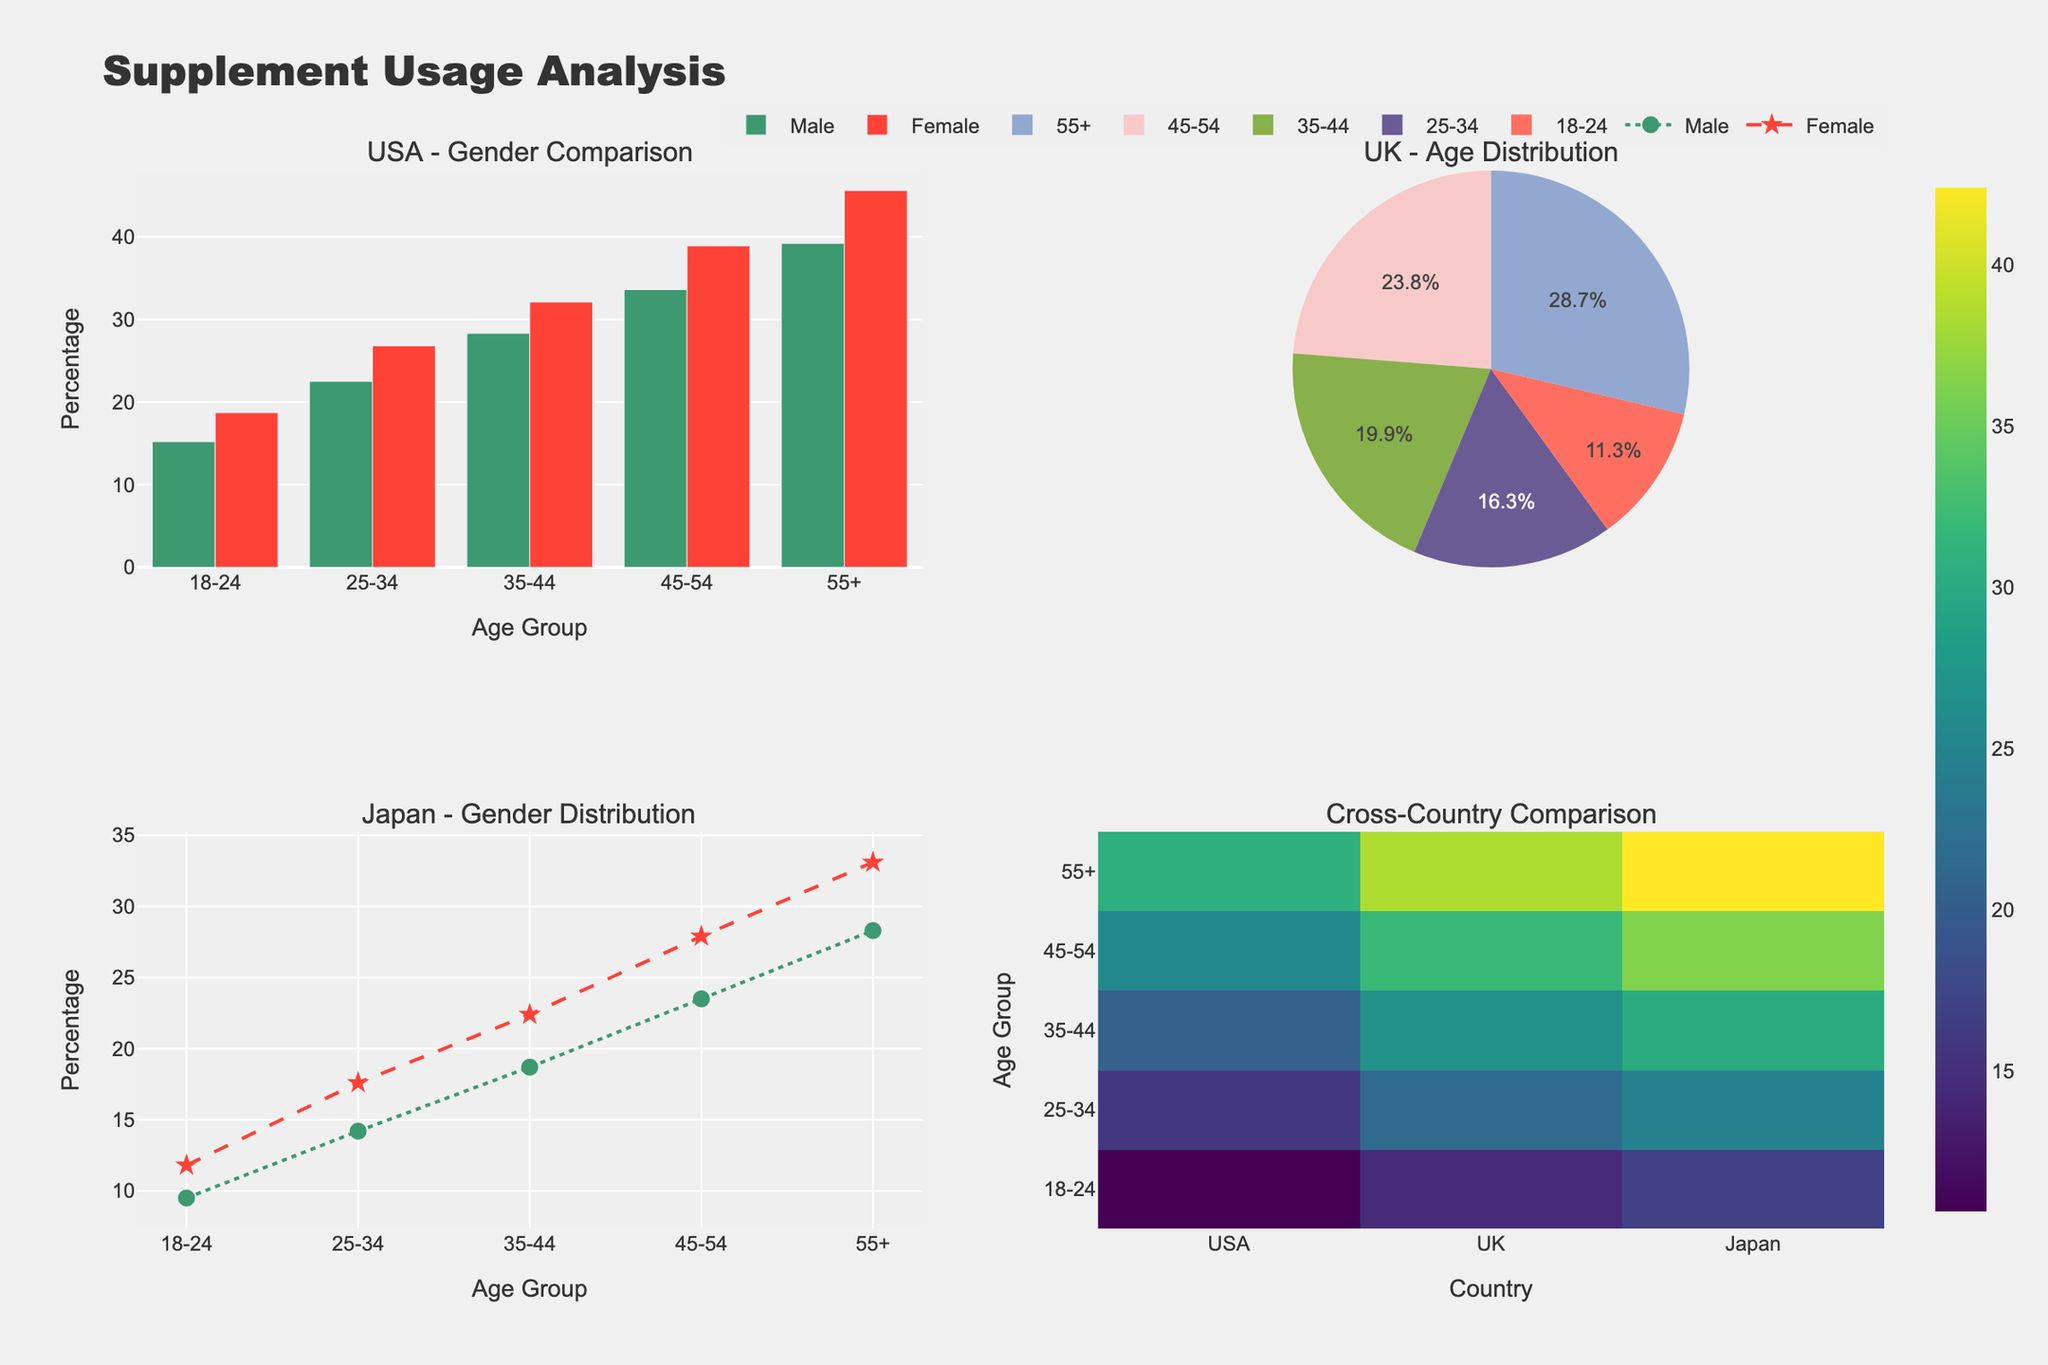What's the title of the entire figure? The title is displayed at the top of the figure. It reads "Supplement Usage Analysis".
Answer: Supplement Usage Analysis What type of chart is used to represent the gender distribution of supplement users in Japan? Observing the bottom-left plot, we see that gender distribution in Japan is depicted using a scatter plot with lines connecting the points.
Answer: Scatter plot In the USA - Gender Comparison plot, what is the percentage of male supplement users in the 35-44 age group? In the first subplot, the percentage for males in the 35-44 age group can be read from the green bar corresponding to this age group.
Answer: 28.3% How does the percentage of female supplement users in the 25-34 age group in the UK compare to the percentage in the USA? Compare the height of the pink bar in the USA plot for females aged 25-34 to the corresponding segment in the UK pie chart. The USA percentage is 26.8%, while the UK percentage is 23.5%.
Answer: The USA has a higher percentage Which age group has the highest percentage of female supplement users in Japan? Looking at the scatter plot at the bottom left, the highest percentage for females is in the 55+ age group.
Answer: 55+ Compare the supplement usage percentage across all countries for the 55+ age group. Which country has the highest percentage? Refer to the heatmap at the bottom right and compare values in the 55+ age group row for all countries.
Answer: USA What is the total percentage of female supplement users in the 18-24 and 25-34 age groups in the UK? In the pie chart for the UK, add the percentages for females in 18-24 (16.3%) and 25-34 (23.5%) age groups. The sum is 16.3 + 23.5.
Answer: 39.8% In which age group is the difference between male and female supplement users the greatest in the USA? By inspecting the differences in bars for the USA, the largest gap is found in the 45-54 age group, with females at 38.9% and males at 33.6%. The difference is 38.9 - 33.6.
Answer: 45-54 For the cross-country comparison, what country and age group combination has the lowest percentage of supplement users? Inspect the heatmap; the lowest value is in Japan for the 18-24 age group.
Answer: Japan, 18-24 What is the primary color used to represent male supplement users in all plots? By examining the plots, the color for male users appears as green.
Answer: Green 